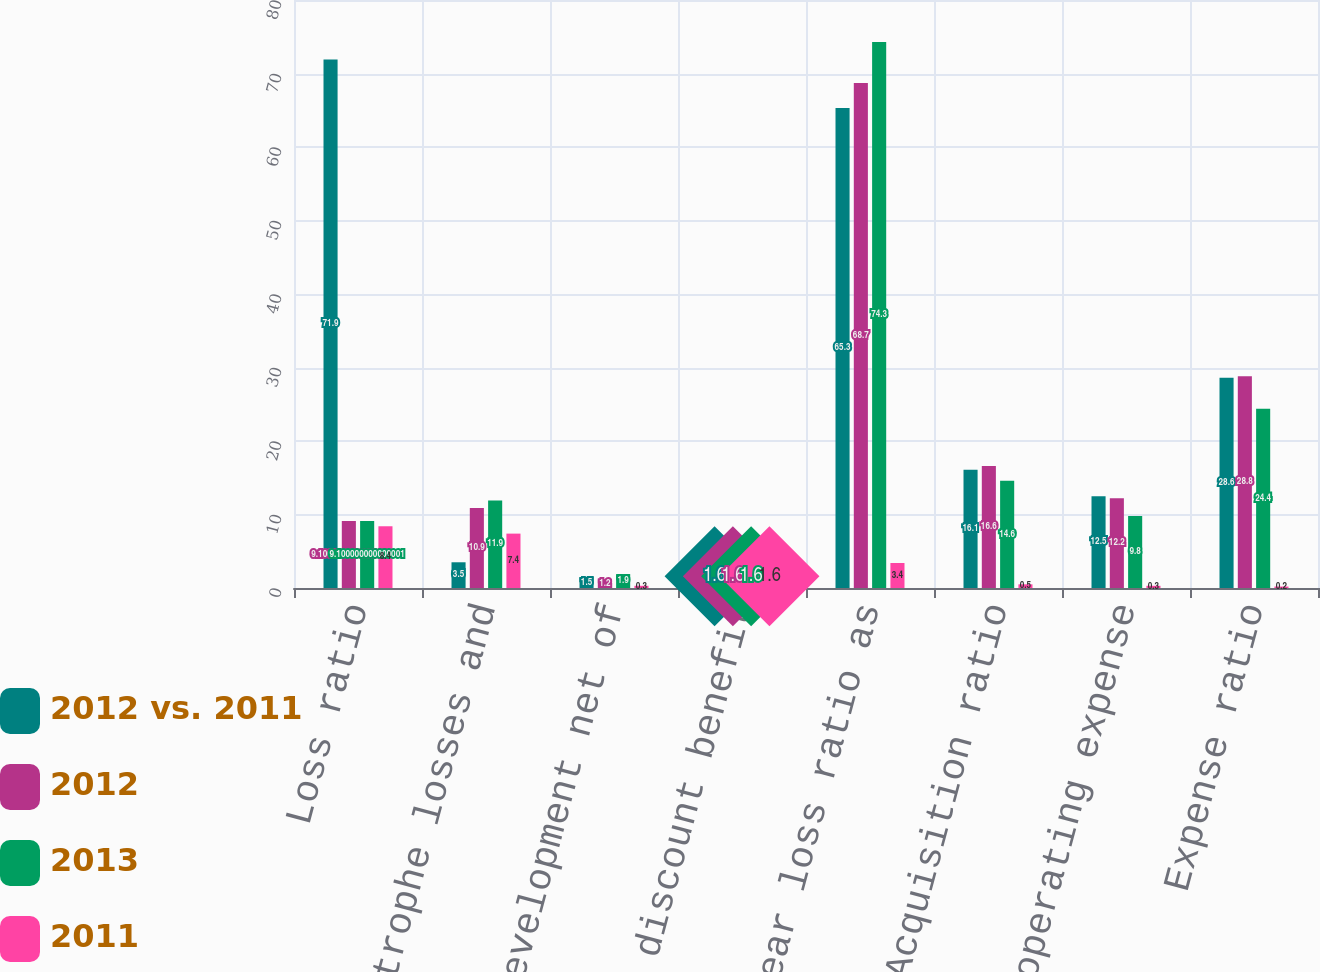Convert chart. <chart><loc_0><loc_0><loc_500><loc_500><stacked_bar_chart><ecel><fcel>Loss ratio<fcel>Catastrophe losses and<fcel>Prior year development net of<fcel>Net reserve discount benefit<fcel>Accident year loss ratio as<fcel>Acquisition ratio<fcel>General operating expense<fcel>Expense ratio<nl><fcel>2012 vs. 2011<fcel>71.9<fcel>3.5<fcel>1.5<fcel>1.6<fcel>65.3<fcel>16.1<fcel>12.5<fcel>28.6<nl><fcel>2012<fcel>9.1<fcel>10.9<fcel>1.2<fcel>0.5<fcel>68.7<fcel>16.6<fcel>12.2<fcel>28.8<nl><fcel>2013<fcel>9.1<fcel>11.9<fcel>1.9<fcel>0.2<fcel>74.3<fcel>14.6<fcel>9.8<fcel>24.4<nl><fcel>2011<fcel>8.4<fcel>7.4<fcel>0.3<fcel>2.1<fcel>3.4<fcel>0.5<fcel>0.3<fcel>0.2<nl></chart> 